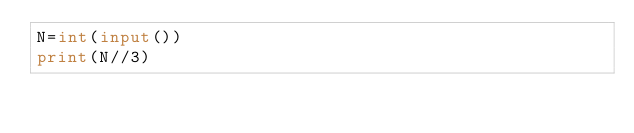<code> <loc_0><loc_0><loc_500><loc_500><_Python_>N=int(input())
print(N//3)</code> 